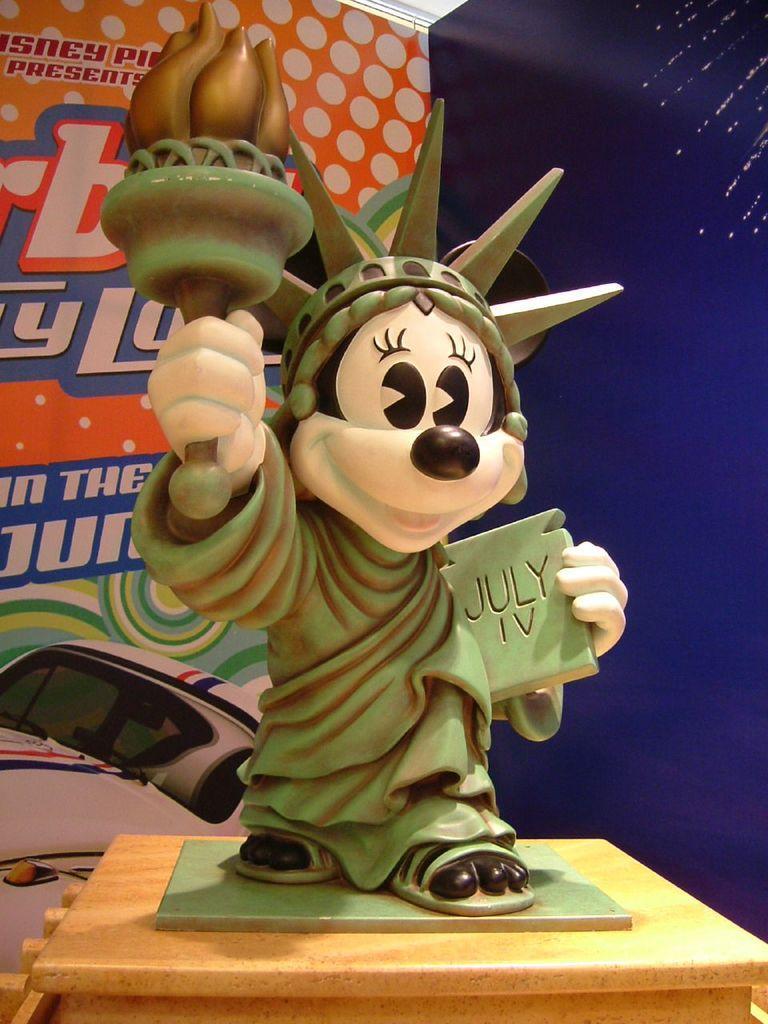Please provide a concise description of this image. In the foreground of this image, there is a sculpture on a wooden surface. In the background, it seems like a banner wall. 